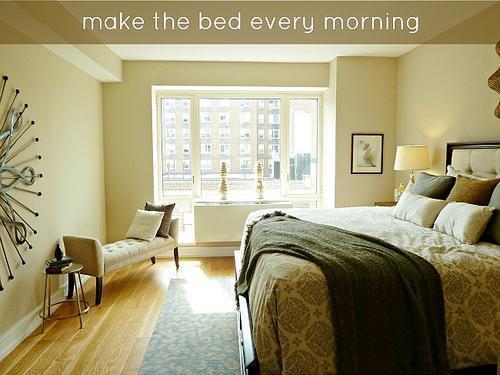How many beds are in the bedroom?
Give a very brief answer. 1. How many pillows are on the bench?
Give a very brief answer. 2. 